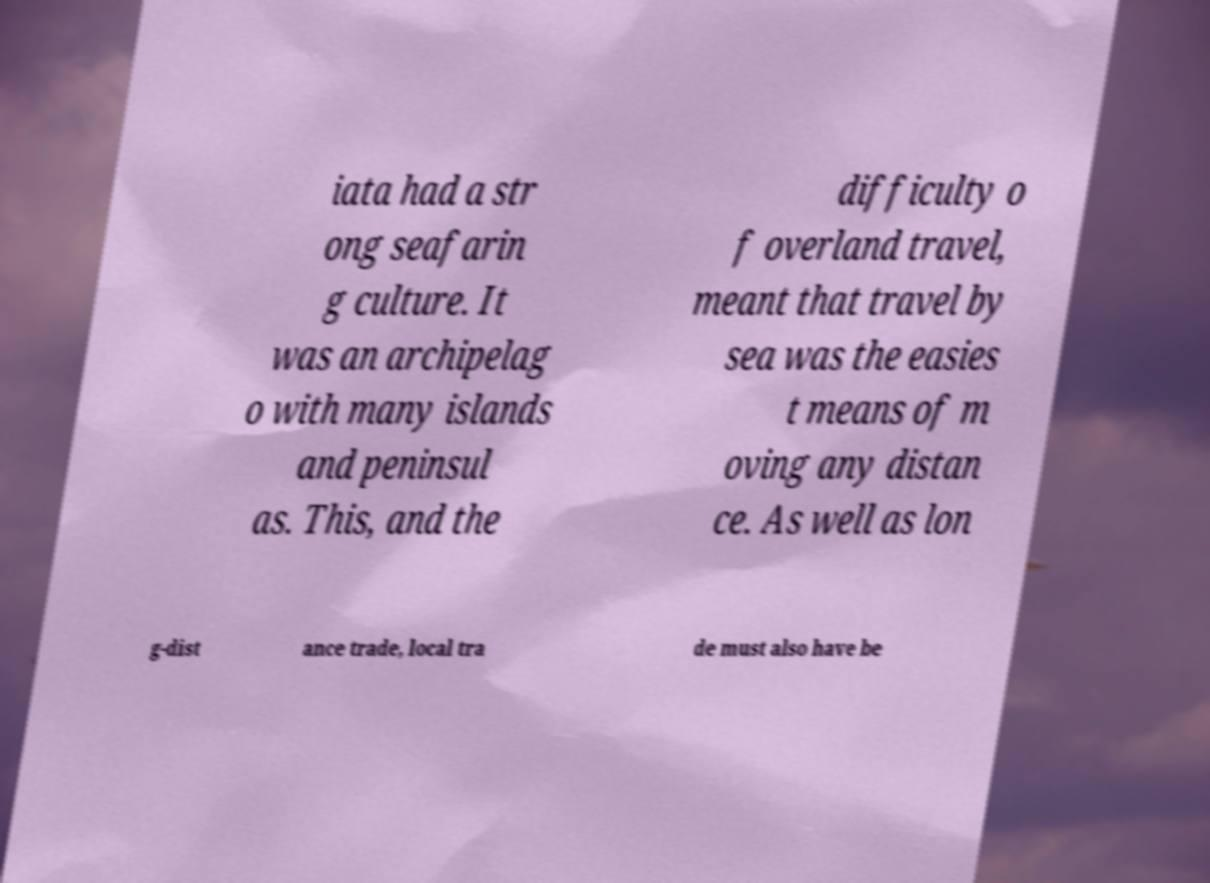For documentation purposes, I need the text within this image transcribed. Could you provide that? iata had a str ong seafarin g culture. It was an archipelag o with many islands and peninsul as. This, and the difficulty o f overland travel, meant that travel by sea was the easies t means of m oving any distan ce. As well as lon g-dist ance trade, local tra de must also have be 